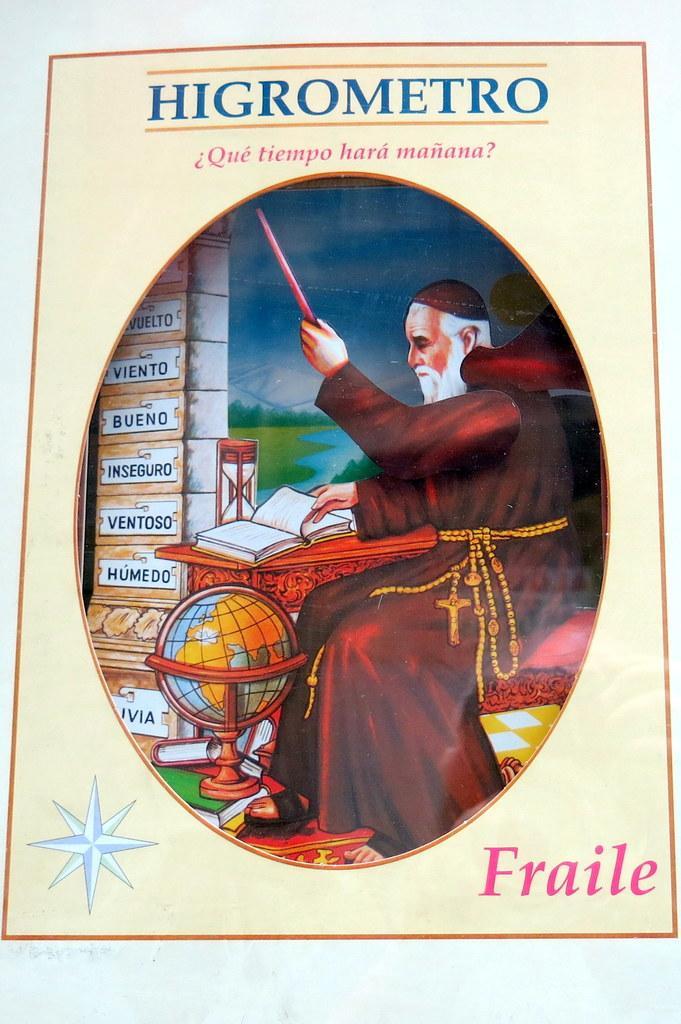How would you summarize this image in a sentence or two? Here, we can see a picture, on that picture at the top, HIGROMETRO is there, there is an old man and at the bottom there FRAILE printed. 